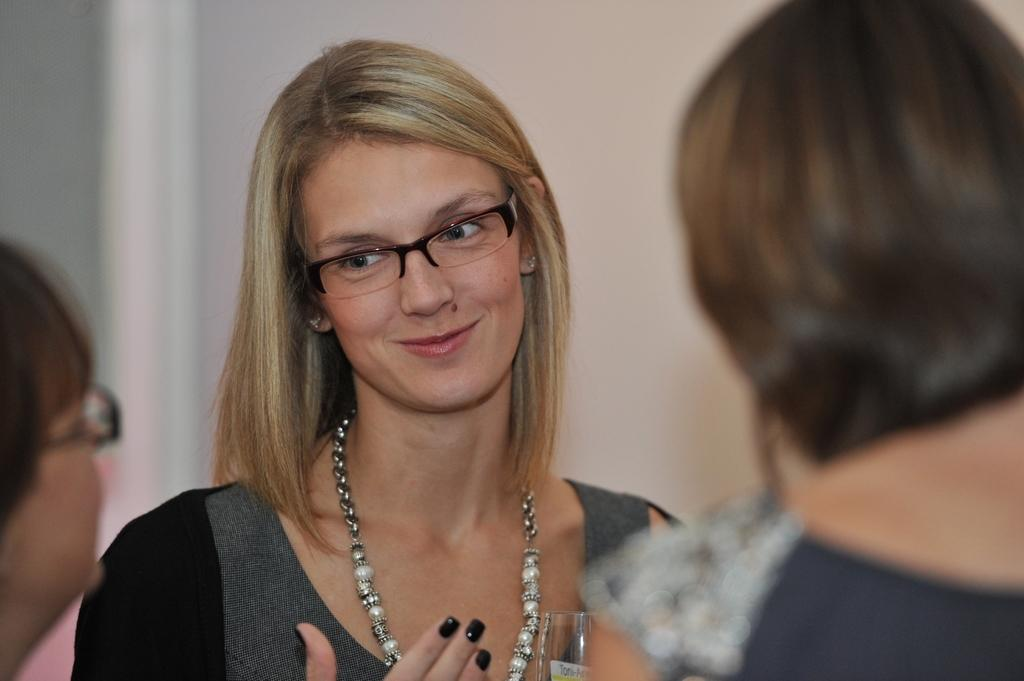How many people are present in the image? There are three women in the image. What can be seen in the background of the image? There is a wall and a curtain in the background of the image. Can you describe the setting where the image might have been taken? The image may have been taken in a hall, based on the presence of a wall and a curtain. What type of religious ceremony is taking place in the image? There is no indication of a religious ceremony in the image; it simply features three women and a background with a wall and a curtain. How many boats can be seen in the image? There are no boats present in the image. 